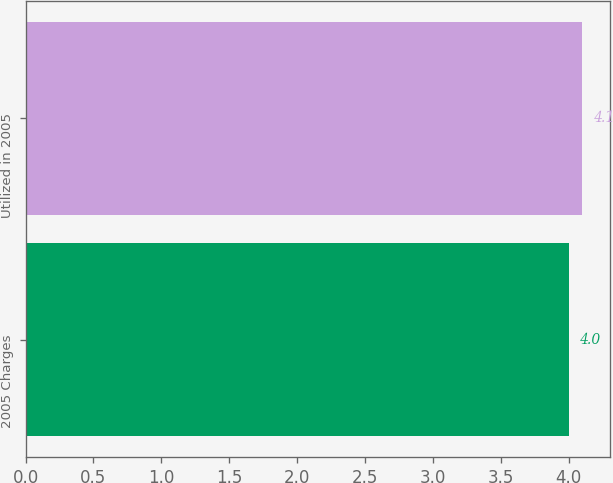Convert chart to OTSL. <chart><loc_0><loc_0><loc_500><loc_500><bar_chart><fcel>2005 Charges<fcel>Utilized in 2005<nl><fcel>4<fcel>4.1<nl></chart> 